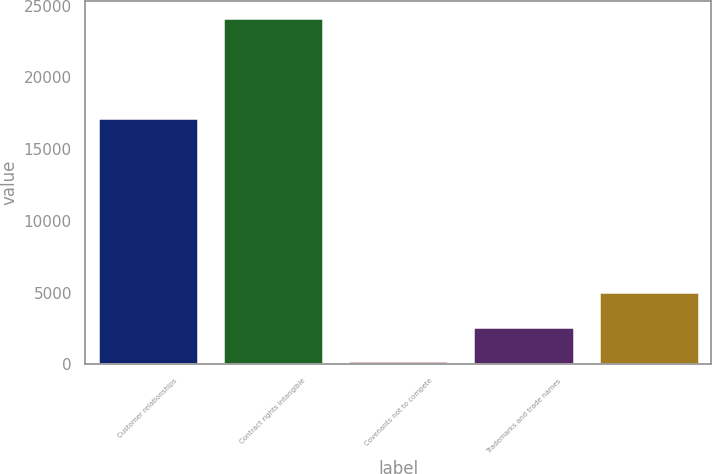<chart> <loc_0><loc_0><loc_500><loc_500><bar_chart><fcel>Customer relationships<fcel>Contract rights intangible<fcel>Covenants not to compete<fcel>Trademarks and trade names<fcel>Unnamed: 4<nl><fcel>17141<fcel>24113<fcel>248<fcel>2634.5<fcel>5021<nl></chart> 